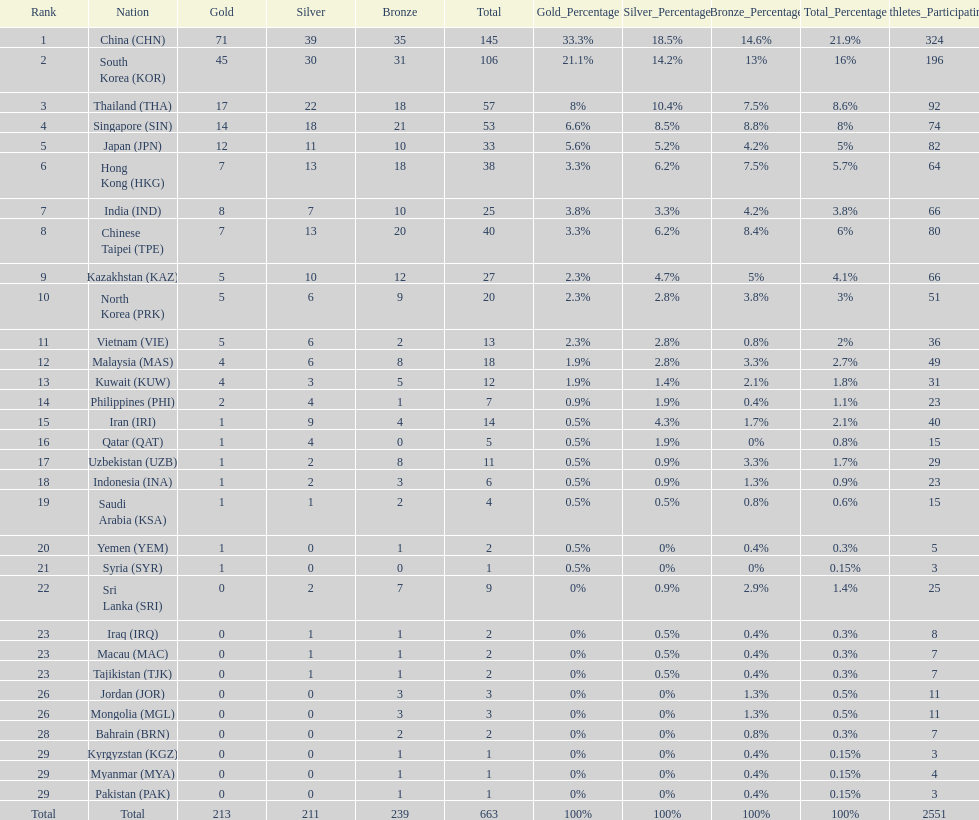Which countries have the same number of silver medals in the asian youth games as north korea? Vietnam (VIE), Malaysia (MAS). 